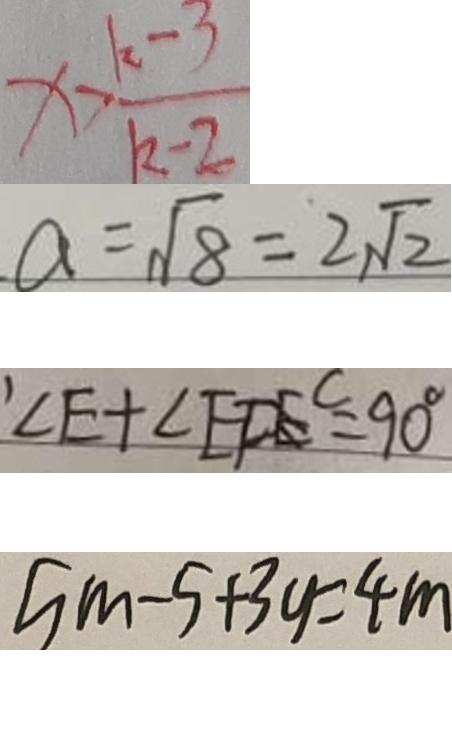<formula> <loc_0><loc_0><loc_500><loc_500>x > \frac { k - 3 } { k - 2 } 
 a = \sqrt { 8 } = 2 \sqrt { 2 } 
 \prime \angle E + \angle E F E ^ { C } = 9 0 ^ { \circ } 
 5 m - 5 + 3 y = 4 m</formula> 